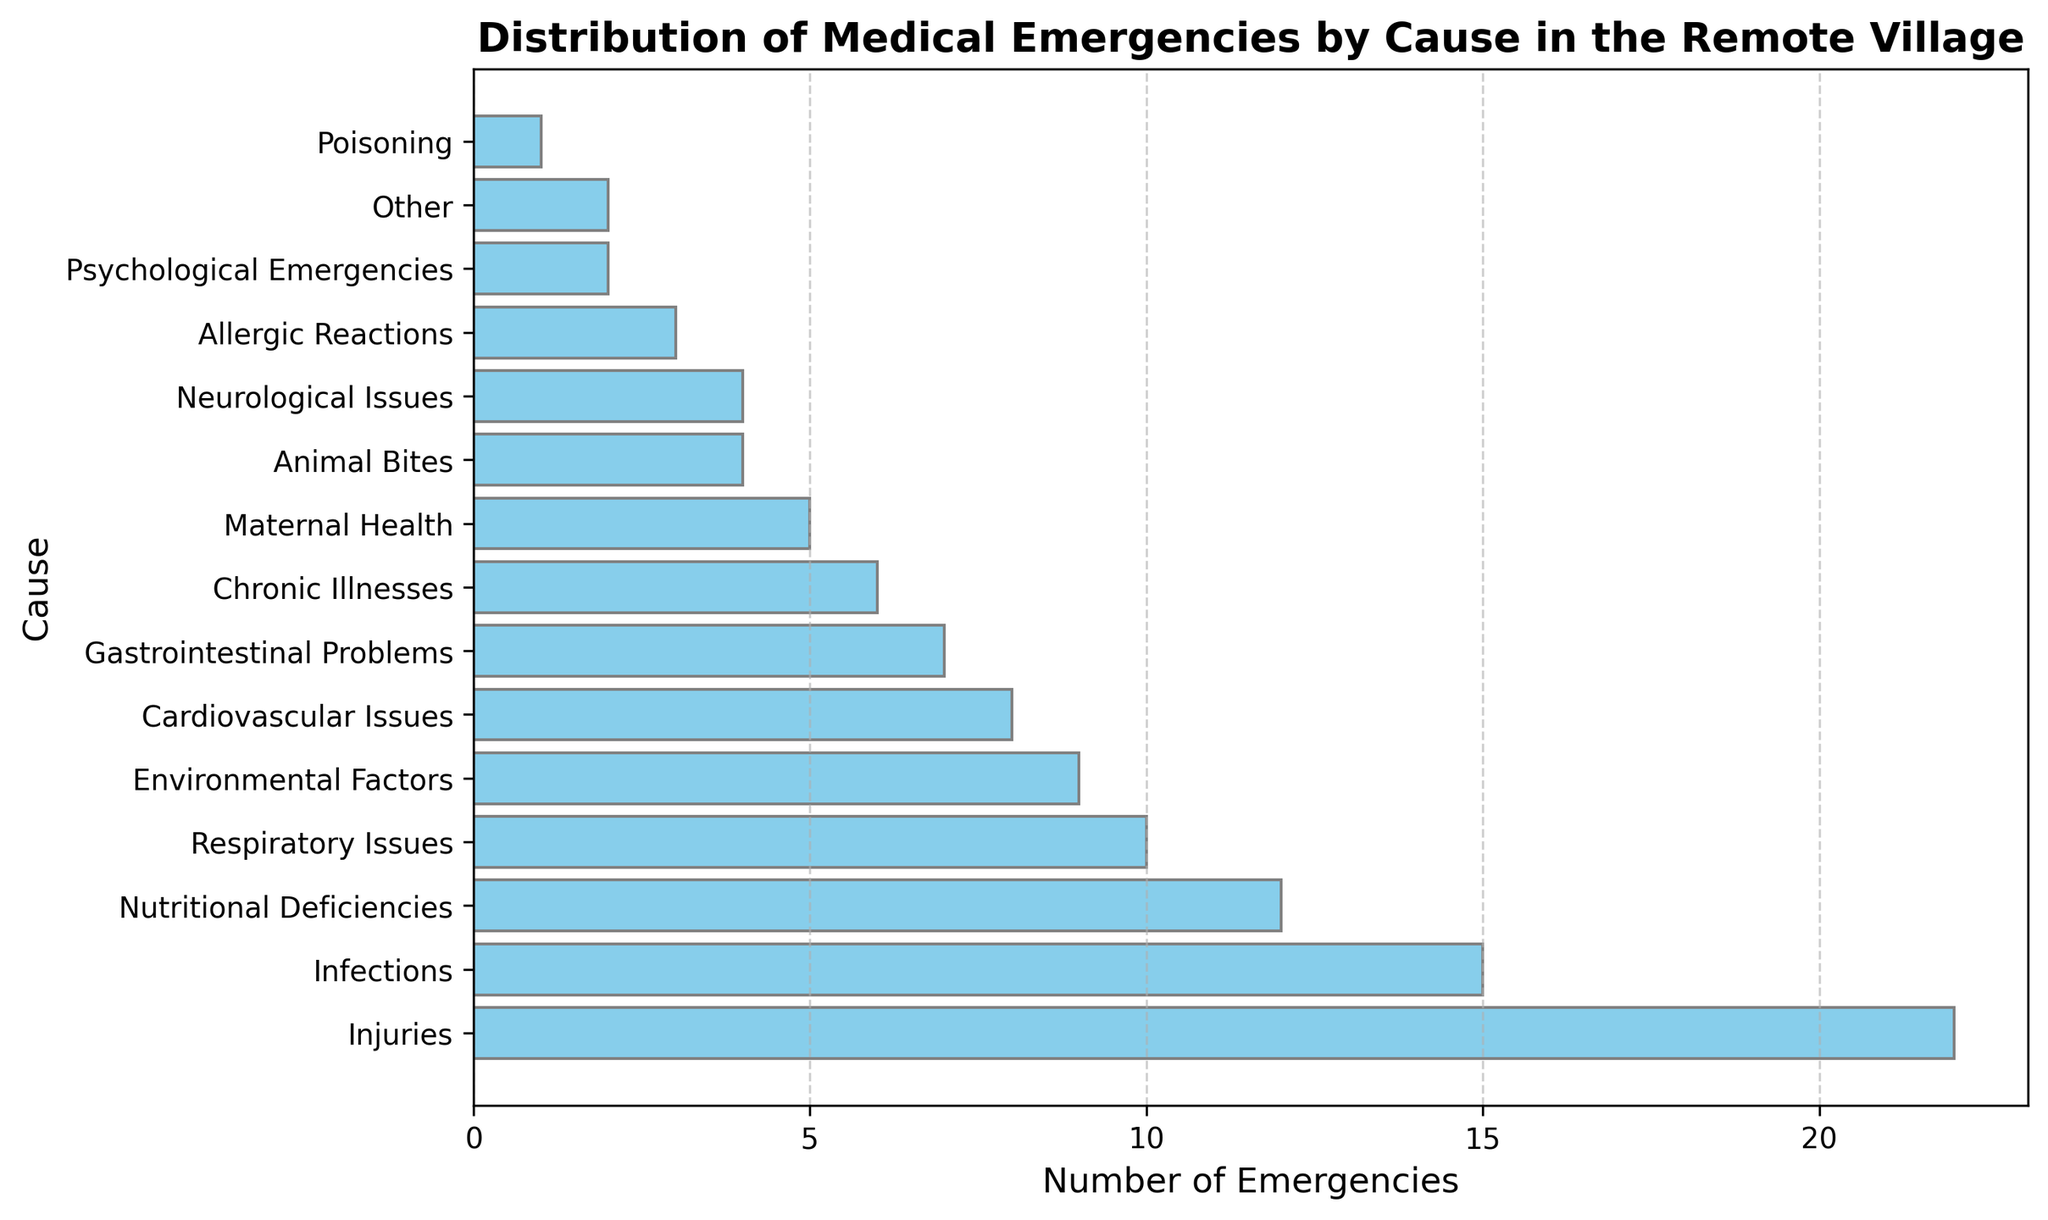What is the most common cause of medical emergencies in the village? The tallest bar on the histogram represents 'Injuries' with 22 emergencies, indicating that it is the most common cause.
Answer: Injuries How many more emergencies are caused by Injuries compared to Respiratory Issues? The bar for Injuries indicates 22 emergencies, while Respiratory Issues have 10. Therefore, the difference is calculated as 22 - 10 = 12.
Answer: 12 Which cause of medical emergencies has fewer incidents, Cardiovascular Issues or Nutritional Deficiencies? By comparing the lengths of the bars, Cardiovascular Issues show 8 emergencies, while Nutritional Deficiencies show 12. Cardiovascular Issues have fewer incidents.
Answer: Cardiovascular Issues What is the total number of emergencies for Infections, Animal Bites, and Maternal Health combined? The numbers from the histogram for these causes are: Infections (15), Animal Bites (4), and Maternal Health (5). Summing them up gives 15 + 4 + 5 = 24.
Answer: 24 Which causes have the same number of emergencies, and what is that number? Both Other and Psychological Emergencies have bars of the same length, representing 2 emergencies each.
Answer: Other and Psychological Emergencies, 2 If Infections increased by 10 emergencies, would it become the most common cause? Currently, Infections have 15 emergencies. Adding 10 would make it 25. Since Injuries have 22 emergencies, Infections would become the most common cause with 25 incidents.
Answer: Yes What is the second least common cause of medical emergencies? The histogram shows Poisoning as the least common with 1 emergency, and Psychological Emergencies and Other both having 2, thus the second least common cause is Psychological Emergencies or Other.
Answer: Psychological Emergencies or Other What percentage of the total emergencies are due to Injuries? The total number of emergencies is the sum of all the values. Calculating this total: 15 + 22 + 10 + 8 + 7 + 5 + 12 + 4 + 3 + 6 + 2 + 9 + 1 + 4 + 2 = 110. The percentage for Injuries is therefore (22/110) * 100 = 20%.
Answer: 20% What are the combined emergencies for Chronic Illnesses, Neurological Issues, and Environmental Factors? From the histogram, Chronic Illnesses have 6, Neurological Issues have 4, and Environmental Factors have 9 emergencies. Summing them up gives 6 + 4 + 9 = 19.
Answer: 19 Which cause of medical emergencies is represented by a bar color different from skyblue? The histogram indicates all bars are colored in skyblue; therefore, no cause is represented by a different bar color.
Answer: None 